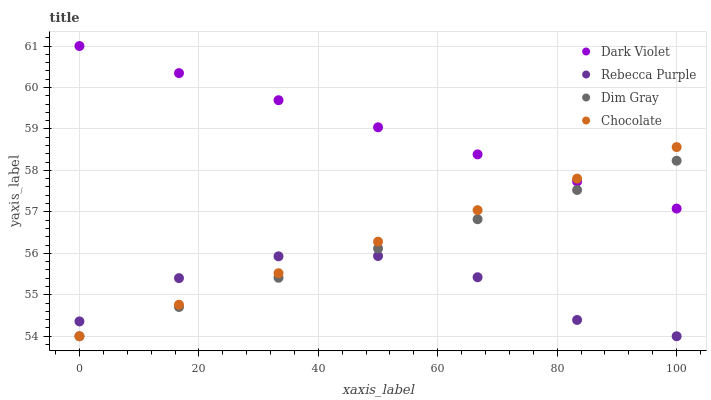Does Rebecca Purple have the minimum area under the curve?
Answer yes or no. Yes. Does Dark Violet have the maximum area under the curve?
Answer yes or no. Yes. Does Dark Violet have the minimum area under the curve?
Answer yes or no. No. Does Rebecca Purple have the maximum area under the curve?
Answer yes or no. No. Is Chocolate the smoothest?
Answer yes or no. Yes. Is Rebecca Purple the roughest?
Answer yes or no. Yes. Is Dark Violet the smoothest?
Answer yes or no. No. Is Dark Violet the roughest?
Answer yes or no. No. Does Dim Gray have the lowest value?
Answer yes or no. Yes. Does Dark Violet have the lowest value?
Answer yes or no. No. Does Dark Violet have the highest value?
Answer yes or no. Yes. Does Rebecca Purple have the highest value?
Answer yes or no. No. Is Rebecca Purple less than Dark Violet?
Answer yes or no. Yes. Is Dark Violet greater than Rebecca Purple?
Answer yes or no. Yes. Does Dim Gray intersect Rebecca Purple?
Answer yes or no. Yes. Is Dim Gray less than Rebecca Purple?
Answer yes or no. No. Is Dim Gray greater than Rebecca Purple?
Answer yes or no. No. Does Rebecca Purple intersect Dark Violet?
Answer yes or no. No. 